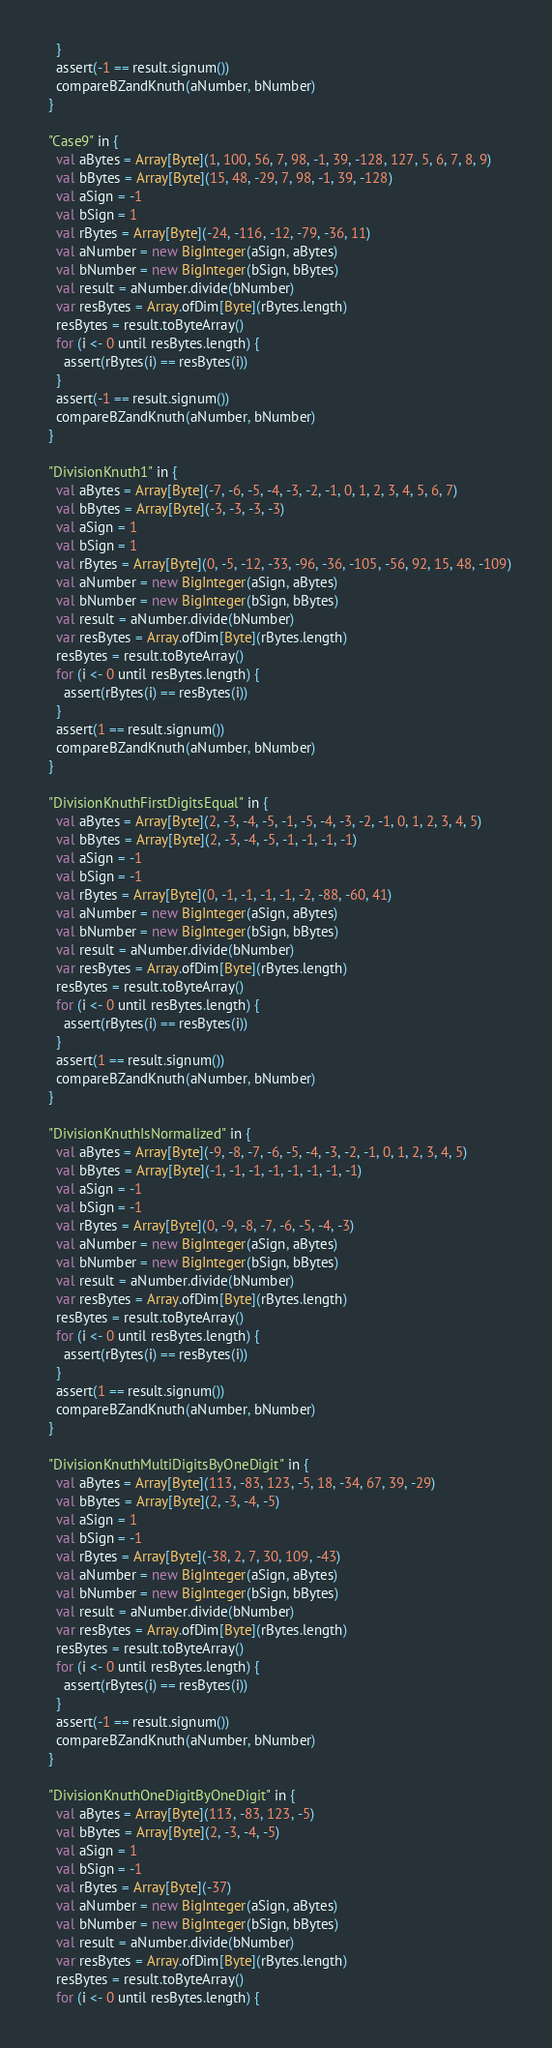Convert code to text. <code><loc_0><loc_0><loc_500><loc_500><_Scala_>    }
    assert(-1 == result.signum())
    compareBZandKnuth(aNumber, bNumber)
  }

  "Case9" in {
    val aBytes = Array[Byte](1, 100, 56, 7, 98, -1, 39, -128, 127, 5, 6, 7, 8, 9)
    val bBytes = Array[Byte](15, 48, -29, 7, 98, -1, 39, -128)
    val aSign = -1
    val bSign = 1
    val rBytes = Array[Byte](-24, -116, -12, -79, -36, 11)
    val aNumber = new BigInteger(aSign, aBytes)
    val bNumber = new BigInteger(bSign, bBytes)
    val result = aNumber.divide(bNumber)
    var resBytes = Array.ofDim[Byte](rBytes.length)
    resBytes = result.toByteArray()
    for (i <- 0 until resBytes.length) {
      assert(rBytes(i) == resBytes(i))
    }
    assert(-1 == result.signum())
    compareBZandKnuth(aNumber, bNumber)
  }

  "DivisionKnuth1" in {
    val aBytes = Array[Byte](-7, -6, -5, -4, -3, -2, -1, 0, 1, 2, 3, 4, 5, 6, 7)
    val bBytes = Array[Byte](-3, -3, -3, -3)
    val aSign = 1
    val bSign = 1
    val rBytes = Array[Byte](0, -5, -12, -33, -96, -36, -105, -56, 92, 15, 48, -109)
    val aNumber = new BigInteger(aSign, aBytes)
    val bNumber = new BigInteger(bSign, bBytes)
    val result = aNumber.divide(bNumber)
    var resBytes = Array.ofDim[Byte](rBytes.length)
    resBytes = result.toByteArray()
    for (i <- 0 until resBytes.length) {
      assert(rBytes(i) == resBytes(i))
    }
    assert(1 == result.signum())
    compareBZandKnuth(aNumber, bNumber)
  }

  "DivisionKnuthFirstDigitsEqual" in {
    val aBytes = Array[Byte](2, -3, -4, -5, -1, -5, -4, -3, -2, -1, 0, 1, 2, 3, 4, 5)
    val bBytes = Array[Byte](2, -3, -4, -5, -1, -1, -1, -1)
    val aSign = -1
    val bSign = -1
    val rBytes = Array[Byte](0, -1, -1, -1, -1, -2, -88, -60, 41)
    val aNumber = new BigInteger(aSign, aBytes)
    val bNumber = new BigInteger(bSign, bBytes)
    val result = aNumber.divide(bNumber)
    var resBytes = Array.ofDim[Byte](rBytes.length)
    resBytes = result.toByteArray()
    for (i <- 0 until resBytes.length) {
      assert(rBytes(i) == resBytes(i))
    }
    assert(1 == result.signum())
    compareBZandKnuth(aNumber, bNumber)
  }

  "DivisionKnuthIsNormalized" in {
    val aBytes = Array[Byte](-9, -8, -7, -6, -5, -4, -3, -2, -1, 0, 1, 2, 3, 4, 5)
    val bBytes = Array[Byte](-1, -1, -1, -1, -1, -1, -1, -1)
    val aSign = -1
    val bSign = -1
    val rBytes = Array[Byte](0, -9, -8, -7, -6, -5, -4, -3)
    val aNumber = new BigInteger(aSign, aBytes)
    val bNumber = new BigInteger(bSign, bBytes)
    val result = aNumber.divide(bNumber)
    var resBytes = Array.ofDim[Byte](rBytes.length)
    resBytes = result.toByteArray()
    for (i <- 0 until resBytes.length) {
      assert(rBytes(i) == resBytes(i))
    }
    assert(1 == result.signum())
    compareBZandKnuth(aNumber, bNumber)
  }

  "DivisionKnuthMultiDigitsByOneDigit" in {
    val aBytes = Array[Byte](113, -83, 123, -5, 18, -34, 67, 39, -29)
    val bBytes = Array[Byte](2, -3, -4, -5)
    val aSign = 1
    val bSign = -1
    val rBytes = Array[Byte](-38, 2, 7, 30, 109, -43)
    val aNumber = new BigInteger(aSign, aBytes)
    val bNumber = new BigInteger(bSign, bBytes)
    val result = aNumber.divide(bNumber)
    var resBytes = Array.ofDim[Byte](rBytes.length)
    resBytes = result.toByteArray()
    for (i <- 0 until resBytes.length) {
      assert(rBytes(i) == resBytes(i))
    }
    assert(-1 == result.signum())
    compareBZandKnuth(aNumber, bNumber)
  }

  "DivisionKnuthOneDigitByOneDigit" in {
    val aBytes = Array[Byte](113, -83, 123, -5)
    val bBytes = Array[Byte](2, -3, -4, -5)
    val aSign = 1
    val bSign = -1
    val rBytes = Array[Byte](-37)
    val aNumber = new BigInteger(aSign, aBytes)
    val bNumber = new BigInteger(bSign, bBytes)
    val result = aNumber.divide(bNumber)
    var resBytes = Array.ofDim[Byte](rBytes.length)
    resBytes = result.toByteArray()
    for (i <- 0 until resBytes.length) {</code> 